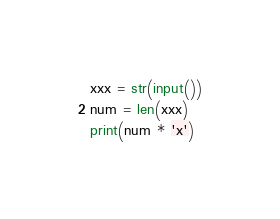Convert code to text. <code><loc_0><loc_0><loc_500><loc_500><_Python_>xxx = str(input())
num = len(xxx)
print(num * 'x')</code> 